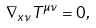<formula> <loc_0><loc_0><loc_500><loc_500>\nabla _ { x \nu } T ^ { \mu \nu } = 0 ,</formula> 